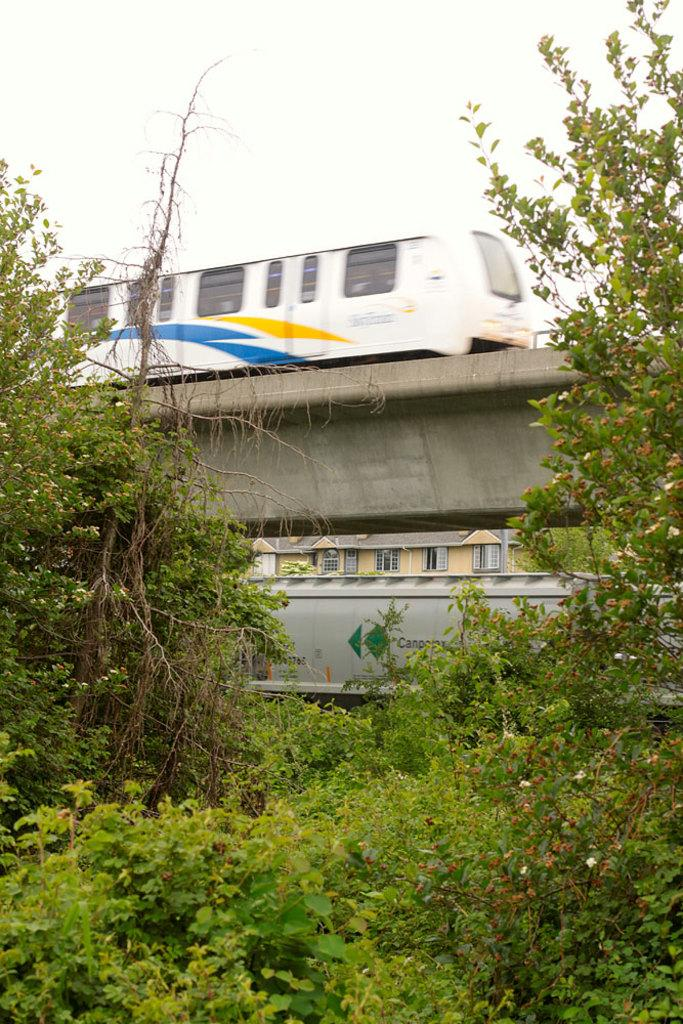What is the main subject of the image? The main subject of the image is a train. Where is the train located in the image? The train is on a railway track. What type of natural elements can be seen in the image? Trees and plants are visible in the image. What is visible in the background of the image? The sky is visible in the background of the image. What type of division can be seen between the trees in the image? There is no division between the trees in the image; they are not separated by any visible boundaries. What appliance is being used by the train in the image? There are no appliances present in the image, as it features a train on a railway track with trees and plants in the background. 